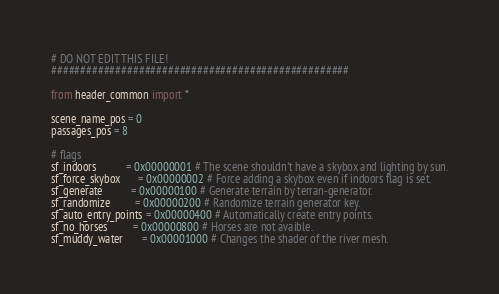Convert code to text. <code><loc_0><loc_0><loc_500><loc_500><_Python_># DO NOT EDIT THIS FILE!
###################################################

from header_common import *

scene_name_pos = 0
passages_pos = 8

# flags
sf_indoors           = 0x00000001 # The scene shouldn't have a skybox and lighting by sun.
sf_force_skybox      = 0x00000002 # Force adding a skybox even if indoors flag is set.
sf_generate          = 0x00000100 # Generate terrain by terran-generator.
sf_randomize         = 0x00000200 # Randomize terrain generator key.
sf_auto_entry_points = 0x00000400 # Automatically create entry points.
sf_no_horses         = 0x00000800 # Horses are not avaible.
sf_muddy_water       = 0x00001000 # Changes the shader of the river mesh.


</code> 